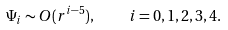<formula> <loc_0><loc_0><loc_500><loc_500>\Psi _ { i } \sim O ( r ^ { i - 5 } ) , \quad i = 0 , 1 , 2 , 3 , 4 .</formula> 